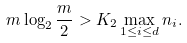Convert formula to latex. <formula><loc_0><loc_0><loc_500><loc_500>m \log _ { 2 } \frac { m } { 2 } > K _ { 2 } \max _ { 1 \leq i \leq d } n _ { i } .</formula> 